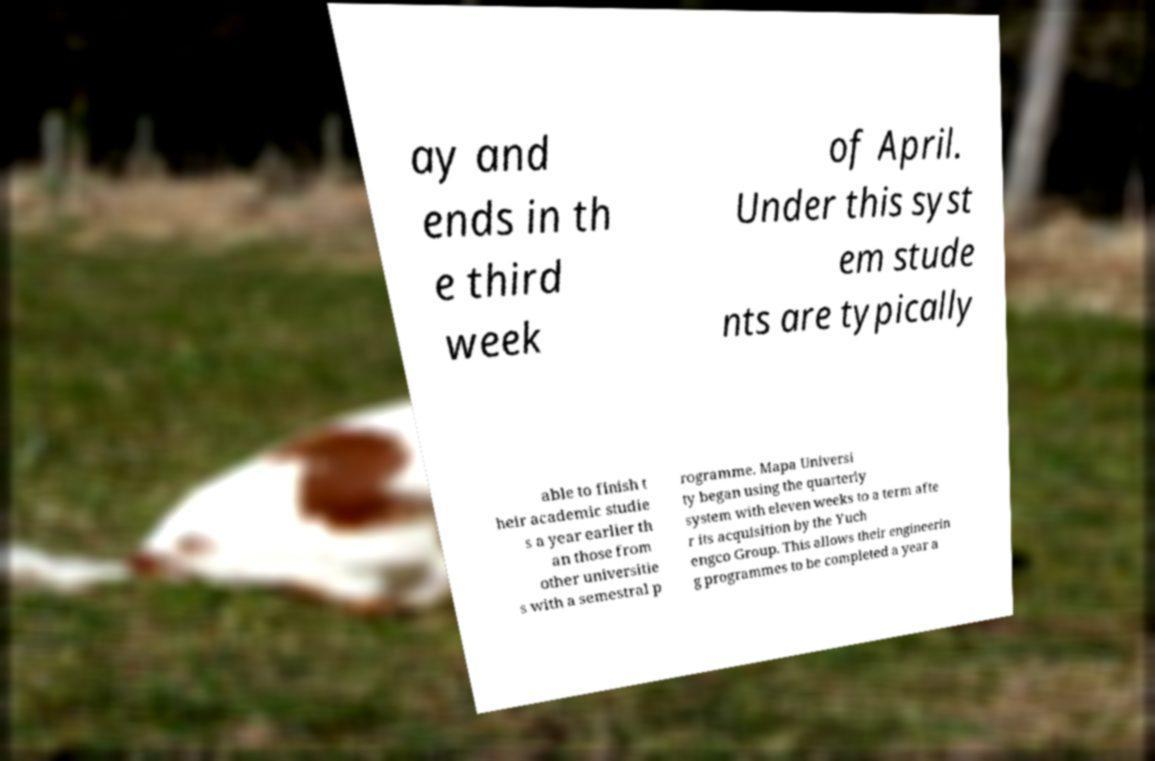Can you read and provide the text displayed in the image?This photo seems to have some interesting text. Can you extract and type it out for me? ay and ends in th e third week of April. Under this syst em stude nts are typically able to finish t heir academic studie s a year earlier th an those from other universitie s with a semestral p rogramme. Mapa Universi ty began using the quarterly system with eleven weeks to a term afte r its acquisition by the Yuch engco Group. This allows their engineerin g programmes to be completed a year a 